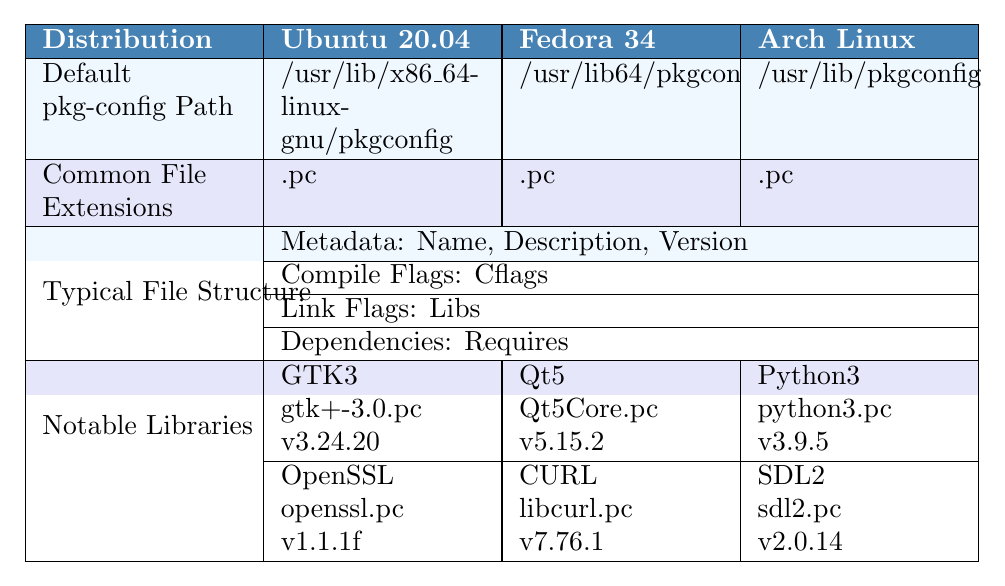What is the default pkg-config path for Ubuntu 20.04? The table indicates that the default pkg-config path for Ubuntu 20.04 is listed directly under that distribution's section. It is /usr/lib/x86_64-linux-gnu/pkgconfig.
Answer: /usr/lib/x86_64-linux-gnu/pkgconfig Which Linux distribution specifies "Libs.private" in its typical file structure? By examining the column entries for the typical file structure of each distribution, only Fedora 34 specifies "Libs.private" under Link Flags.
Answer: Fedora 34 Do all Linux distributions in the table have the same common file extension for pkg-config files? The common file extensions are all listed as ".pc" for each distribution in their respective rows, indicating uniformity across the listed distributions.
Answer: Yes How many notable libraries are listed for Arch Linux? Reviewing the notable libraries section for Arch Linux, we see it lists 2 notable libraries (Python3 and SDL2), along with their details about file names and versions underneath them.
Answer: 2 Which distribution has the GTK3 library and what is its version? Looking at the notable libraries under each distribution, GTK3 is only listed under Ubuntu 20.04 with the version 3.24.20.
Answer: Ubuntu 20.04, version 3.24.20 What is the average version number of the notable libraries listed for Fedora 34 and Arch Linux? Fedore 34 has two versions: 5.15.2 (Qt5) and 7.76.1 (CURL), calculated as (5.15.2 + 7.76.1) / 2. Arch Linux has two versions: 3.9.5 (Python3) and 2.0.14 (SDL2). The average for Fedora is approximately 6.46 and for Arch is approximately 3.97. Therefore, the overall average ={(6.46 + 3.97)}/2 = 5.215.
Answer: 5.215 Does CentOS 8 have a metadata entry for URL in its pkg-config file structure? The table shows that CentOS 8's typical file structure includes metadata entries: Name, Description, and Version but does not include a URL entry, confirming that it does not have it.
Answer: No Which distribution uses /usr/lib/pkgconfig as its default pkg-config path and what notable library does it provide? The table shows Arch Linux uses /usr/lib/pkgconfig as its default path, and it lists notable libraries Python3 and SDL2, among others.
Answer: Arch Linux, Python3 and SDL2 